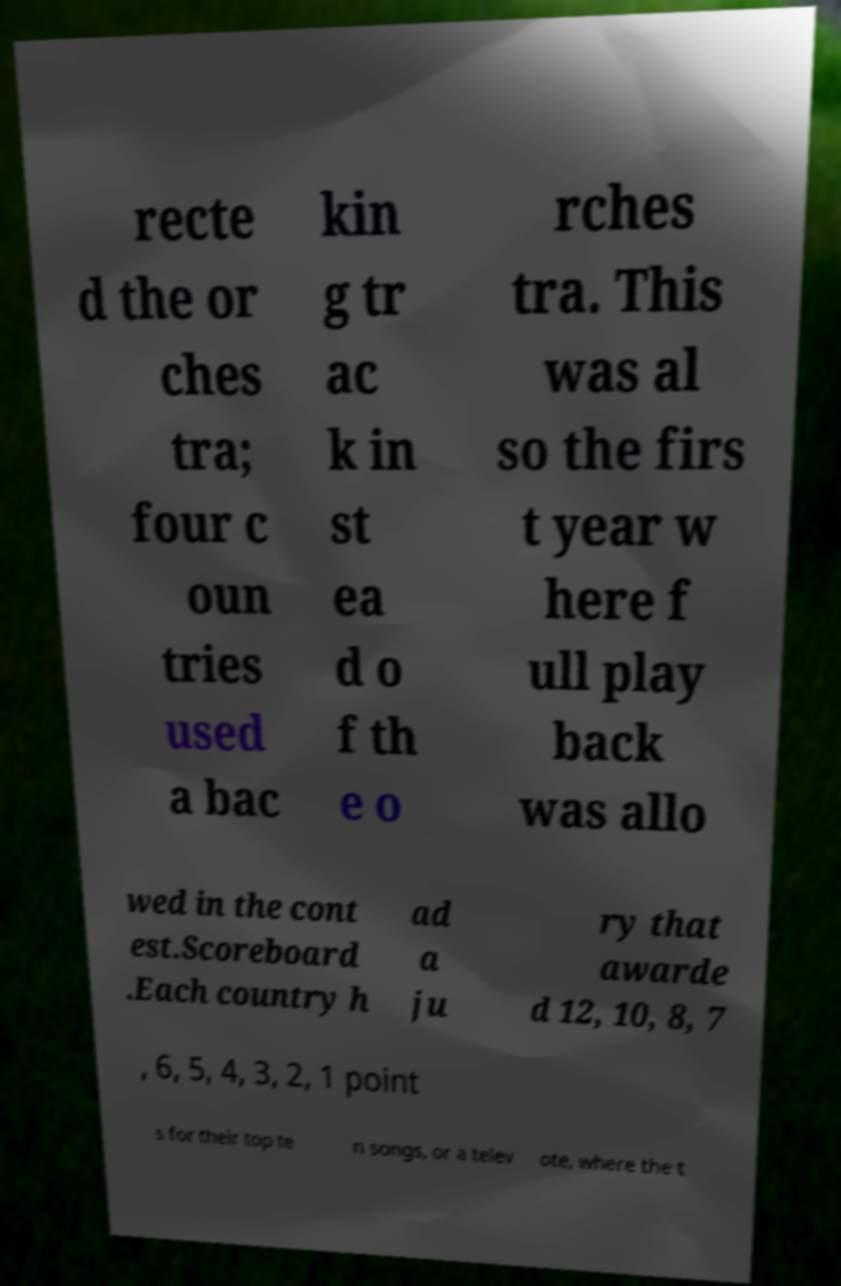What messages or text are displayed in this image? I need them in a readable, typed format. recte d the or ches tra; four c oun tries used a bac kin g tr ac k in st ea d o f th e o rches tra. This was al so the firs t year w here f ull play back was allo wed in the cont est.Scoreboard .Each country h ad a ju ry that awarde d 12, 10, 8, 7 , 6, 5, 4, 3, 2, 1 point s for their top te n songs, or a telev ote, where the t 